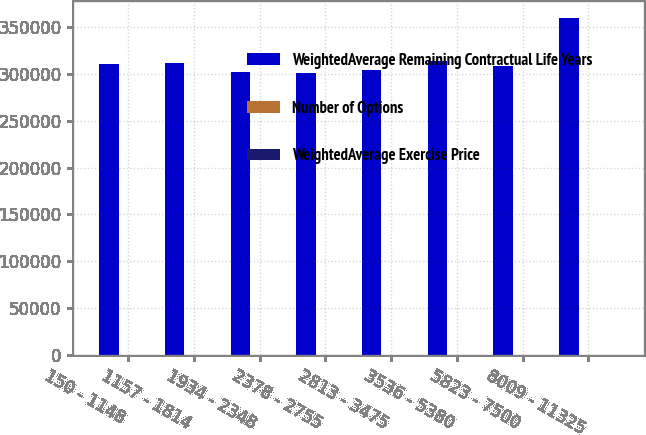Convert chart to OTSL. <chart><loc_0><loc_0><loc_500><loc_500><stacked_bar_chart><ecel><fcel>150 - 1148<fcel>1157 - 1814<fcel>1934 - 2348<fcel>2378 - 2755<fcel>2813 - 3475<fcel>3536 - 5380<fcel>5823 - 7500<fcel>8009 - 11325<nl><fcel>WeightedAverage Remaining Contractual Life Years<fcel>310542<fcel>311566<fcel>302259<fcel>300998<fcel>304110<fcel>314372<fcel>308609<fcel>359849<nl><fcel>Number of Options<fcel>2.22<fcel>3.25<fcel>5.1<fcel>4.62<fcel>5.4<fcel>6.55<fcel>9.07<fcel>9.29<nl><fcel>WeightedAverage Exercise Price<fcel>8.08<fcel>14.65<fcel>21.52<fcel>26.32<fcel>30.91<fcel>42.35<fcel>67.04<fcel>98.03<nl></chart> 